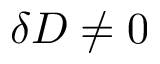<formula> <loc_0><loc_0><loc_500><loc_500>\delta D \neq 0</formula> 